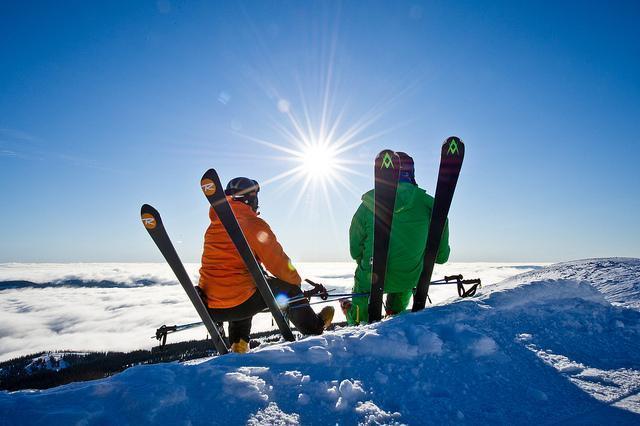How many people are in the picture?
Give a very brief answer. 2. How many ski are there?
Give a very brief answer. 2. How many open umbrellas are there?
Give a very brief answer. 0. 